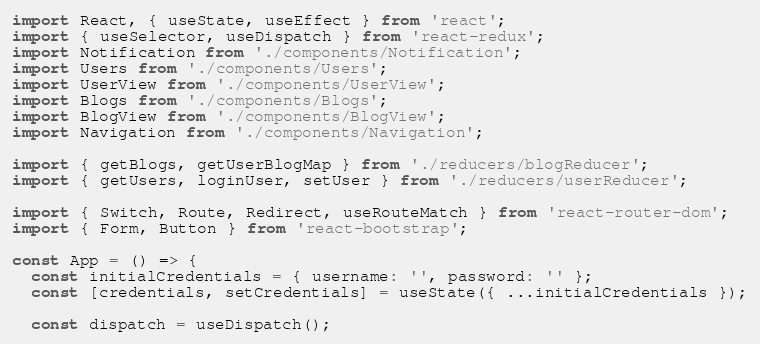<code> <loc_0><loc_0><loc_500><loc_500><_JavaScript_>import React, { useState, useEffect } from 'react';
import { useSelector, useDispatch } from 'react-redux';
import Notification from './components/Notification';
import Users from './components/Users';
import UserView from './components/UserView';
import Blogs from './components/Blogs';
import BlogView from './components/BlogView';
import Navigation from './components/Navigation';

import { getBlogs, getUserBlogMap } from './reducers/blogReducer';
import { getUsers, loginUser, setUser } from './reducers/userReducer';

import { Switch, Route, Redirect, useRouteMatch } from 'react-router-dom';
import { Form, Button } from 'react-bootstrap';

const App = () => {
  const initialCredentials = { username: '', password: '' };
  const [credentials, setCredentials] = useState({ ...initialCredentials });

  const dispatch = useDispatch();</code> 